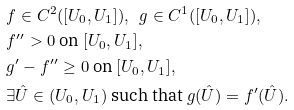<formula> <loc_0><loc_0><loc_500><loc_500>& f \in C ^ { 2 } ( [ U _ { 0 } , U _ { 1 } ] ) , \ \ g \in C ^ { 1 } ( [ U _ { 0 } , U _ { 1 } ] ) , \\ & f ^ { \prime \prime } > 0 \text {  on  } [ U _ { 0 } , U _ { 1 } ] , \\ & g ^ { \prime } - f ^ { \prime \prime } \geq 0 \text {  on  } [ U _ { 0 } , U _ { 1 } ] , \\ & \exists \hat { U } \in ( U _ { 0 } , U _ { 1 } ) \text {  such that  } g ( \hat { U } ) = f ^ { \prime } ( \hat { U } ) .</formula> 